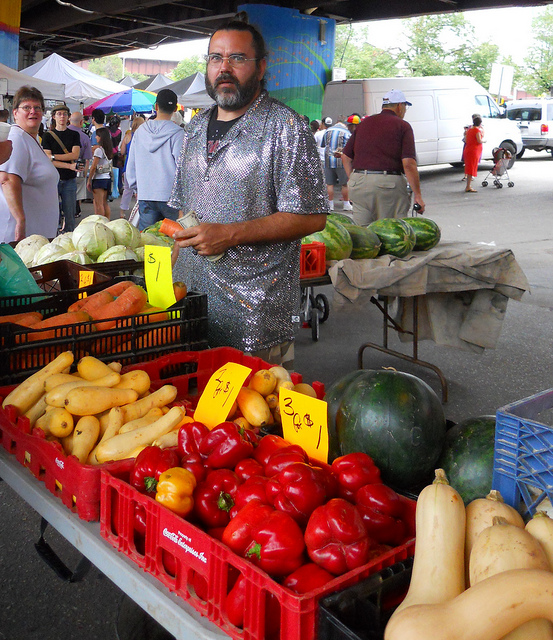<image>What color is the cashier's visor? The cashier does not seem to be wearing a visor. However, it could possibly be white, green, black, or red. What color is the cashier's visor? The cashier does not have a visor. It is not pictured in the image. 